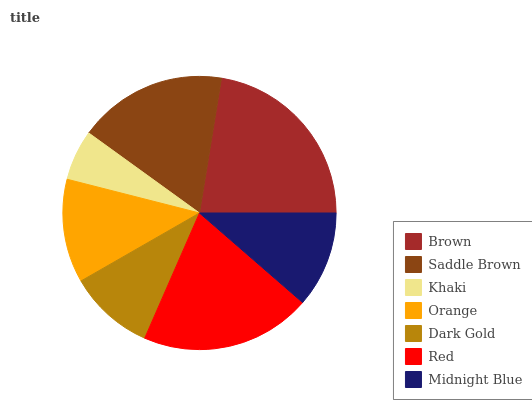Is Khaki the minimum?
Answer yes or no. Yes. Is Brown the maximum?
Answer yes or no. Yes. Is Saddle Brown the minimum?
Answer yes or no. No. Is Saddle Brown the maximum?
Answer yes or no. No. Is Brown greater than Saddle Brown?
Answer yes or no. Yes. Is Saddle Brown less than Brown?
Answer yes or no. Yes. Is Saddle Brown greater than Brown?
Answer yes or no. No. Is Brown less than Saddle Brown?
Answer yes or no. No. Is Orange the high median?
Answer yes or no. Yes. Is Orange the low median?
Answer yes or no. Yes. Is Midnight Blue the high median?
Answer yes or no. No. Is Red the low median?
Answer yes or no. No. 